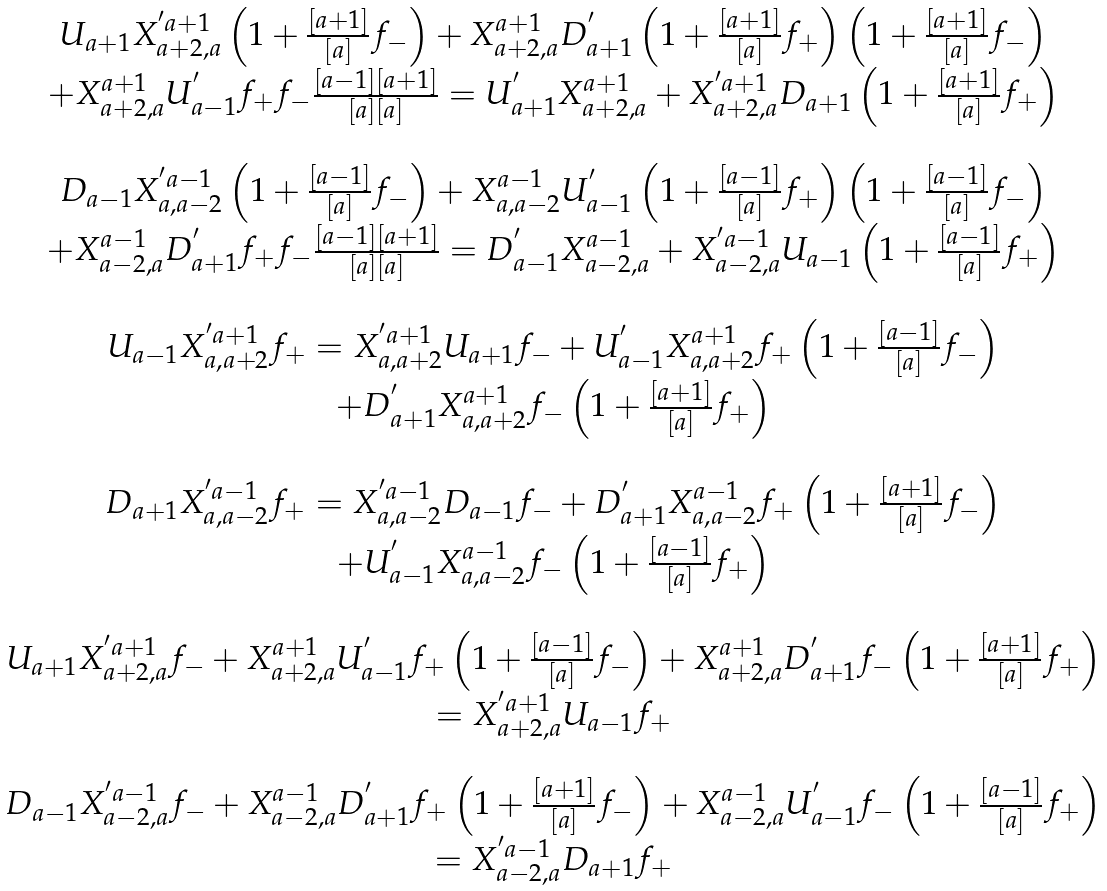<formula> <loc_0><loc_0><loc_500><loc_500>\begin{array} { l c l } & { U } _ { a + 1 } { X } ^ { ^ { \prime } a + 1 } _ { a + 2 , a } \left ( 1 + \frac { [ a + 1 ] } { [ a ] } f _ { - } \right ) + { X } ^ { a + 1 } _ { a + 2 , a } { D } ^ { ^ { \prime } } _ { a + 1 } \left ( 1 + \frac { [ a + 1 ] } { [ a ] } f _ { + } \right ) \left ( 1 + \frac { [ a + 1 ] } { [ a ] } f _ { - } \right ) & \\ & + { X } ^ { a + 1 } _ { a + 2 , a } { U } _ { a - 1 } ^ { ^ { \prime } } f _ { + } f _ { - } \frac { [ a - 1 ] [ a + 1 ] } { [ a ] [ a ] } = { U } ^ { ^ { \prime } } _ { a + 1 } { X } ^ { a + 1 } _ { a + 2 , a } + { X } ^ { ^ { \prime } a + 1 } _ { a + 2 , a } { D } _ { a + 1 } \left ( 1 + \frac { [ a + 1 ] } { [ a ] } f _ { + } \right ) & \\ & & \\ & { D } _ { a - 1 } { X } ^ { ^ { \prime } a - 1 } _ { a , a - 2 } \left ( 1 + \frac { [ a - 1 ] } { [ a ] } f _ { - } \right ) + { X } ^ { a - 1 } _ { a , a - 2 } { U } ^ { ^ { \prime } } _ { a - 1 } \left ( 1 + \frac { [ a - 1 ] } { [ a ] } f _ { + } \right ) \left ( 1 + \frac { [ a - 1 ] } { [ a ] } f _ { - } \right ) & \\ & + { X } ^ { a - 1 } _ { a - 2 , a } { D } _ { a + 1 } ^ { ^ { \prime } } f _ { + } f _ { - } \frac { [ a - 1 ] [ a + 1 ] } { [ a ] [ a ] } = { D } ^ { ^ { \prime } } _ { a - 1 } { X } ^ { a - 1 } _ { a - 2 , a } + { X } ^ { ^ { \prime } a - 1 } _ { a - 2 , a } { U } _ { a - 1 } \left ( 1 + \frac { [ a - 1 ] } { [ a ] } f _ { + } \right ) & \\ & & \\ & { U } _ { a - 1 } { X } ^ { ^ { \prime } a + 1 } _ { a , a + 2 } f _ { + } = { X } ^ { ^ { \prime } a + 1 } _ { a , a + 2 } { U } _ { a + 1 } f _ { - } + { U } _ { a - 1 } ^ { ^ { \prime } } { X } ^ { a + 1 } _ { a , a + 2 } f _ { + } \left ( 1 + \frac { [ a - 1 ] } { [ a ] } f _ { - } \right ) & \\ & + { D } ^ { ^ { \prime } } _ { a + 1 } { X } ^ { a + 1 } _ { a , a + 2 } f _ { - } \left ( 1 + \frac { [ a + 1 ] } { [ a ] } f _ { + } \right ) & \\ & & \\ & { D } _ { a + 1 } { X } ^ { ^ { \prime } a - 1 } _ { a , a - 2 } f _ { + } = { X } ^ { ^ { \prime } a - 1 } _ { a , a - 2 } { D } _ { a - 1 } f _ { - } + { D } _ { a + 1 } ^ { ^ { \prime } } { X } ^ { a - 1 } _ { a , a - 2 } f _ { + } \left ( 1 + \frac { [ a + 1 ] } { [ a ] } f _ { - } \right ) & \\ & + { U } ^ { ^ { \prime } } _ { a - 1 } { X } ^ { a - 1 } _ { a , a - 2 } f _ { - } \left ( 1 + \frac { [ a - 1 ] } { [ a ] } f _ { + } \right ) & \\ & & \\ & { U } _ { a + 1 } { X } ^ { ^ { \prime } a + 1 } _ { a + 2 , a } f _ { - } + { X } ^ { a + 1 } _ { a + 2 , a } { U } _ { a - 1 } ^ { ^ { \prime } } f _ { + } \left ( 1 + \frac { [ a - 1 ] } { [ a ] } f _ { - } \right ) + { X } ^ { a + 1 } _ { a + 2 , a } { D } ^ { ^ { \prime } } _ { a + 1 } f _ { - } \left ( 1 + \frac { [ a + 1 ] } { [ a ] } f _ { + } \right ) & \\ & = { X } ^ { ^ { \prime } a + 1 } _ { a + 2 , a } { U } _ { a - 1 } f _ { + } & \\ & & \\ & { D } _ { a - 1 } { X } ^ { ^ { \prime } a - 1 } _ { a - 2 , a } f _ { - } + { X } ^ { a - 1 } _ { a - 2 , a } { D } _ { a + 1 } ^ { ^ { \prime } } f _ { + } \left ( 1 + \frac { [ a + 1 ] } { [ a ] } f _ { - } \right ) + { X } ^ { a - 1 } _ { a - 2 , a } { U } ^ { ^ { \prime } } _ { a - 1 } f _ { - } \left ( 1 + \frac { [ a - 1 ] } { [ a ] } f _ { + } \right ) & \\ & = { X } ^ { ^ { \prime } a - 1 } _ { a - 2 , a } { D } _ { a + 1 } f _ { + } & \end{array}</formula> 